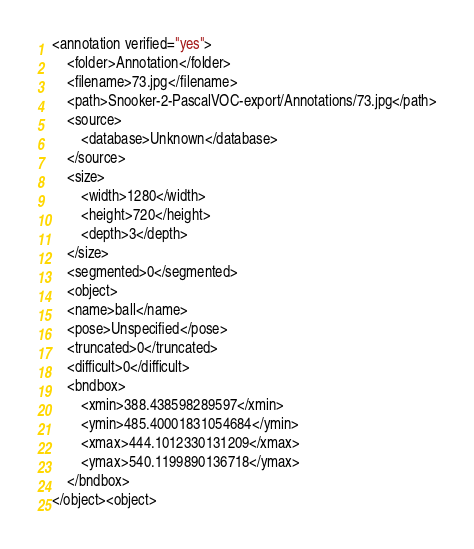<code> <loc_0><loc_0><loc_500><loc_500><_XML_><annotation verified="yes">
    <folder>Annotation</folder>
    <filename>73.jpg</filename>
    <path>Snooker-2-PascalVOC-export/Annotations/73.jpg</path>
    <source>
        <database>Unknown</database>
    </source>
    <size>
        <width>1280</width>
        <height>720</height>
        <depth>3</depth>
    </size>
    <segmented>0</segmented>
    <object>
    <name>ball</name>
    <pose>Unspecified</pose>
    <truncated>0</truncated>
    <difficult>0</difficult>
    <bndbox>
        <xmin>388.438598289597</xmin>
        <ymin>485.40001831054684</ymin>
        <xmax>444.1012330131209</xmax>
        <ymax>540.1199890136718</ymax>
    </bndbox>
</object><object></code> 